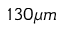Convert formula to latex. <formula><loc_0><loc_0><loc_500><loc_500>1 3 0 \mu m</formula> 